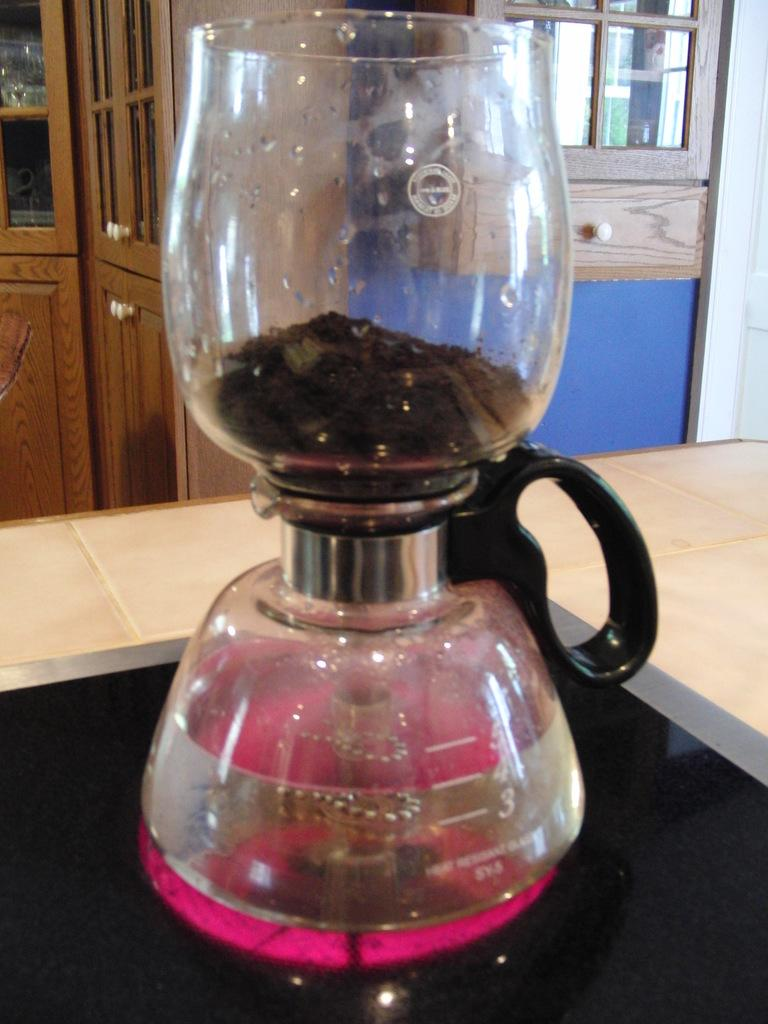<image>
Give a short and clear explanation of the subsequent image. Two beakers with heat resistant labelled on the bottom jar. 